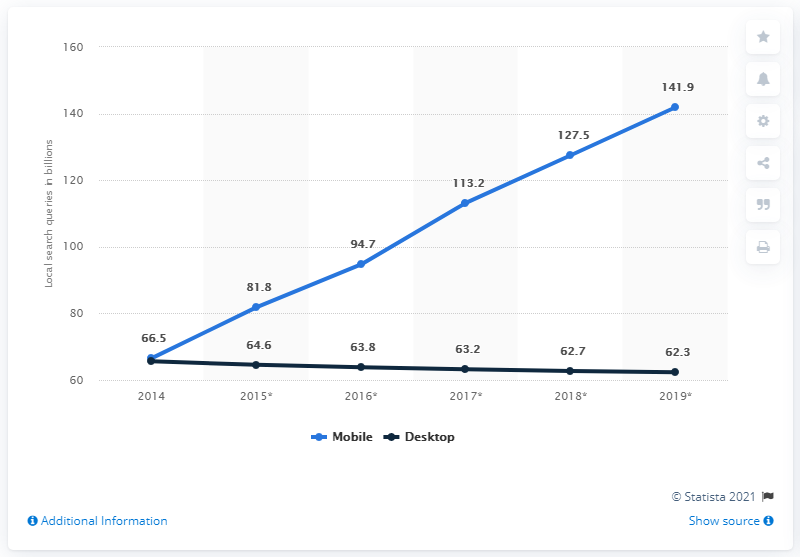Give some essential details in this illustration. In 2016, the estimated volume of mobile local search queries was 94.7... 